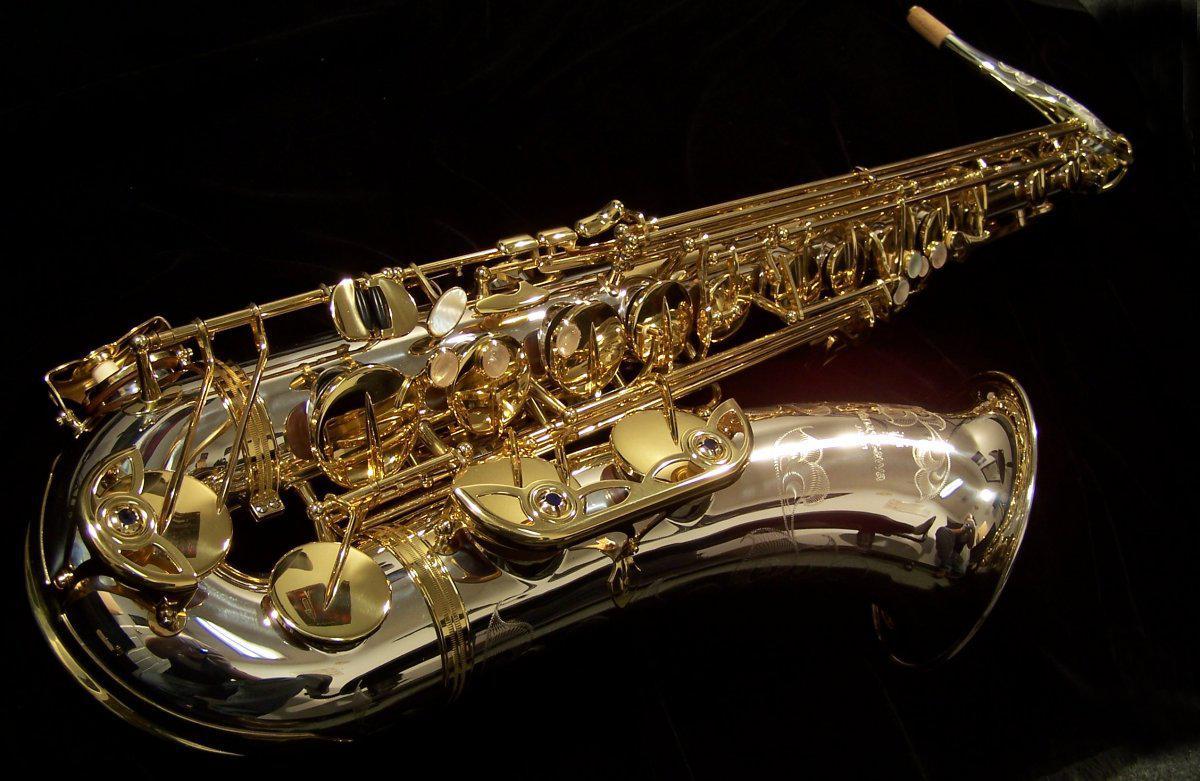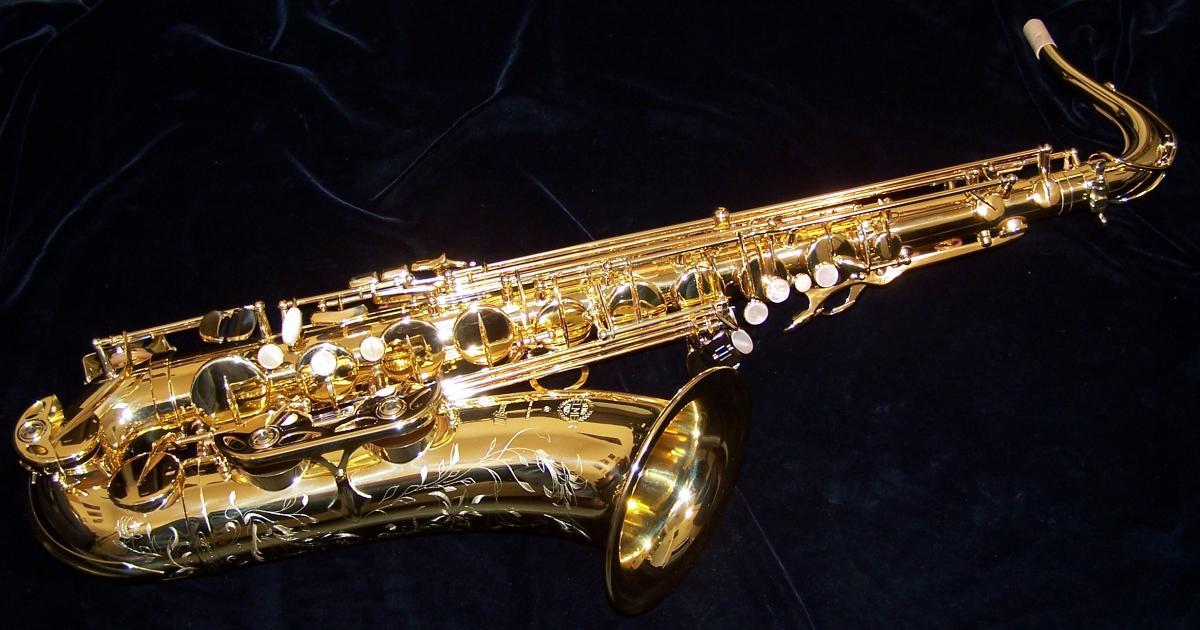The first image is the image on the left, the second image is the image on the right. Evaluate the accuracy of this statement regarding the images: "Each image shows one saxophone displayed nearly horizontally, with its bell downward, and all saxophones face the same direction.". Is it true? Answer yes or no. Yes. 